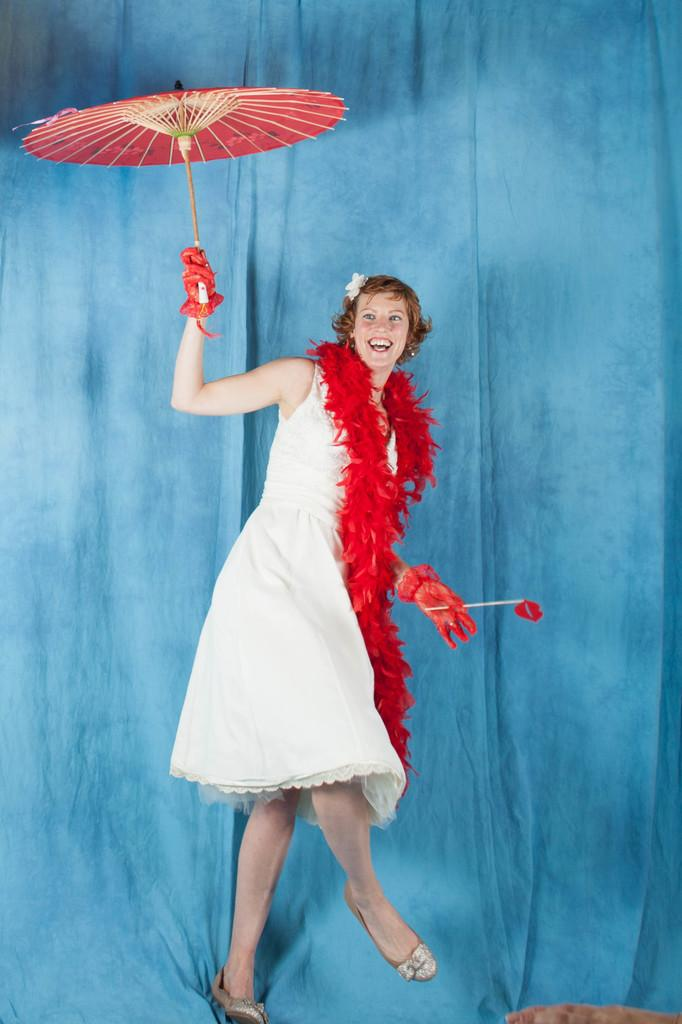Who is the main subject in the image? There is a woman in the image. What is the woman wearing? The woman is wearing a white dress and a fur scarf around her neck. What accessory is the woman holding in her hand? The woman is holding an umbrella in one hand. What type of gloves is the woman wearing? The woman is wearing red color hand gloves. How many cups can be seen in the woman's hand in the image? There are no cups visible in the woman's hand in the image. What color is the wristband the woman is wearing in the image? The woman is not wearing a wristband in the image. 